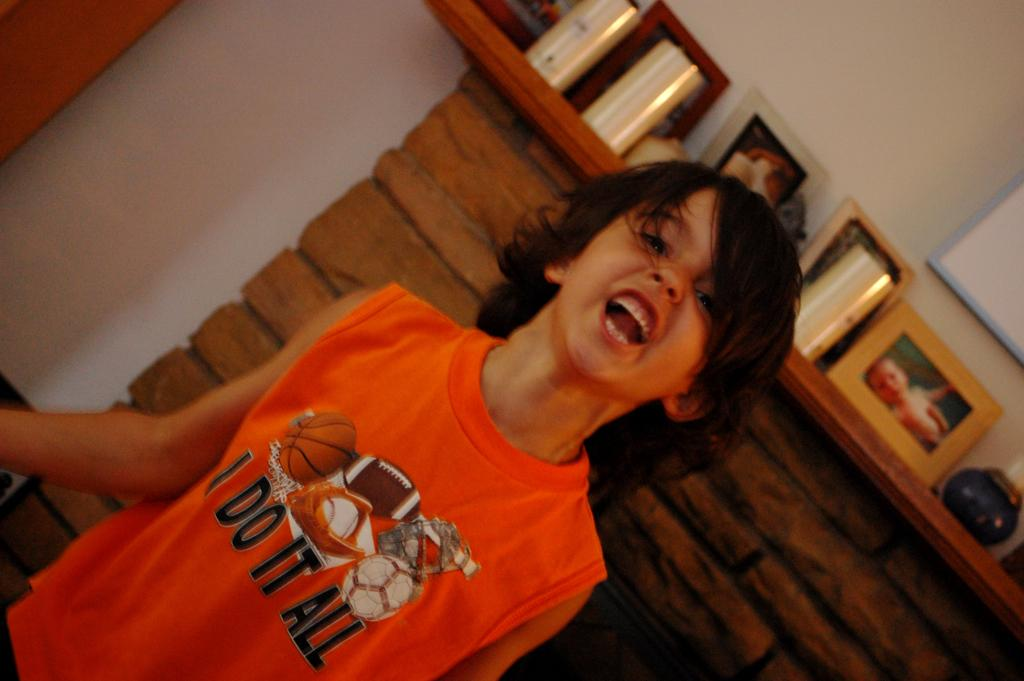<image>
Provide a brief description of the given image. A boy in an orange tank top that says I Do It All is standing by a fireplace. 